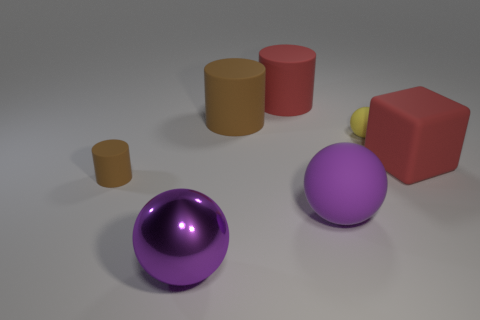Subtract all large balls. How many balls are left? 1 Subtract all purple cylinders. How many purple balls are left? 2 Add 2 brown cubes. How many objects exist? 9 Subtract all red cylinders. How many cylinders are left? 2 Subtract all cubes. How many objects are left? 6 Subtract 2 spheres. How many spheres are left? 1 Subtract all large purple spheres. Subtract all matte cubes. How many objects are left? 4 Add 6 yellow matte things. How many yellow matte things are left? 7 Add 2 gray blocks. How many gray blocks exist? 2 Subtract 0 cyan cylinders. How many objects are left? 7 